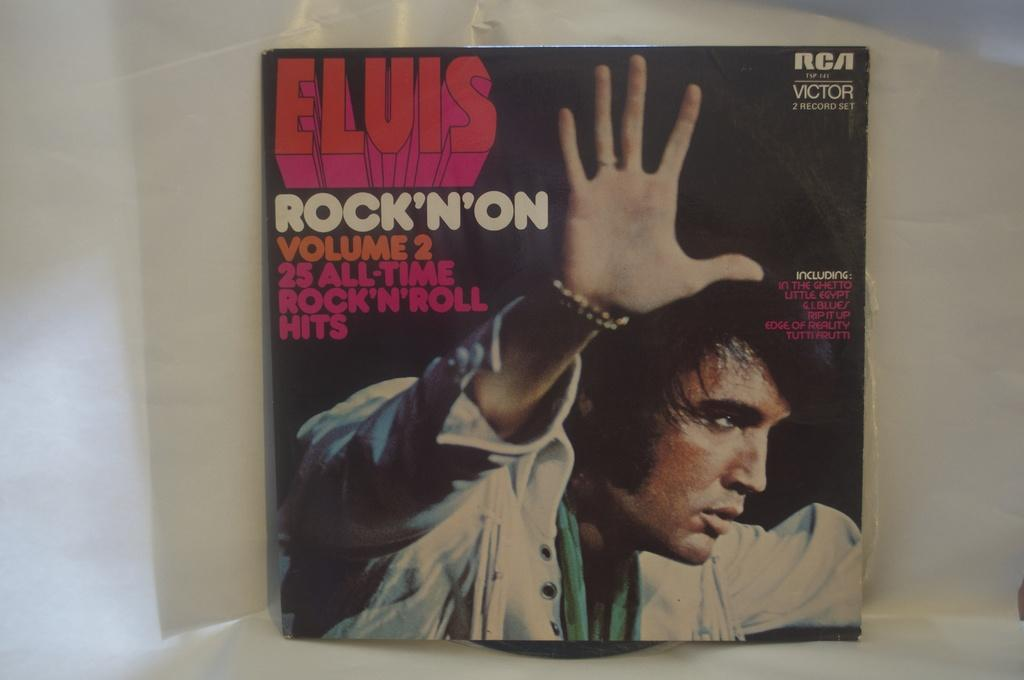Provide a one-sentence caption for the provided image. Elvis rock n on volume two hits record. 